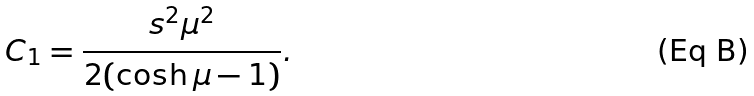<formula> <loc_0><loc_0><loc_500><loc_500>C _ { 1 } = \frac { s ^ { 2 } \mu ^ { 2 } } { 2 ( \cosh \mu - 1 ) } .</formula> 